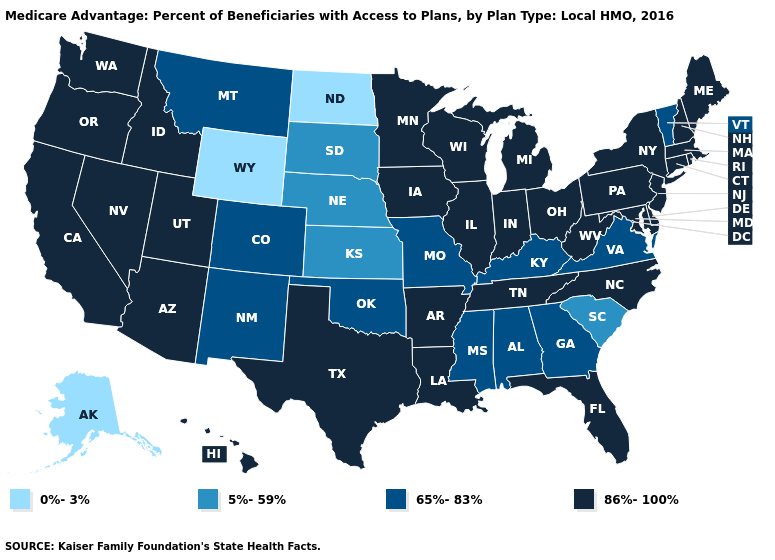What is the value of Virginia?
Be succinct. 65%-83%. Does the map have missing data?
Give a very brief answer. No. Does the map have missing data?
Give a very brief answer. No. Which states have the lowest value in the MidWest?
Answer briefly. North Dakota. What is the highest value in states that border Rhode Island?
Write a very short answer. 86%-100%. Which states have the lowest value in the West?
Be succinct. Alaska, Wyoming. What is the highest value in states that border Iowa?
Write a very short answer. 86%-100%. Does Vermont have the highest value in the USA?
Concise answer only. No. Is the legend a continuous bar?
Be succinct. No. Does Minnesota have the highest value in the USA?
Quick response, please. Yes. What is the highest value in states that border Louisiana?
Keep it brief. 86%-100%. Name the states that have a value in the range 5%-59%?
Quick response, please. Kansas, Nebraska, South Carolina, South Dakota. Does Indiana have the same value as New Jersey?
Concise answer only. Yes. What is the value of New Jersey?
Quick response, please. 86%-100%. 